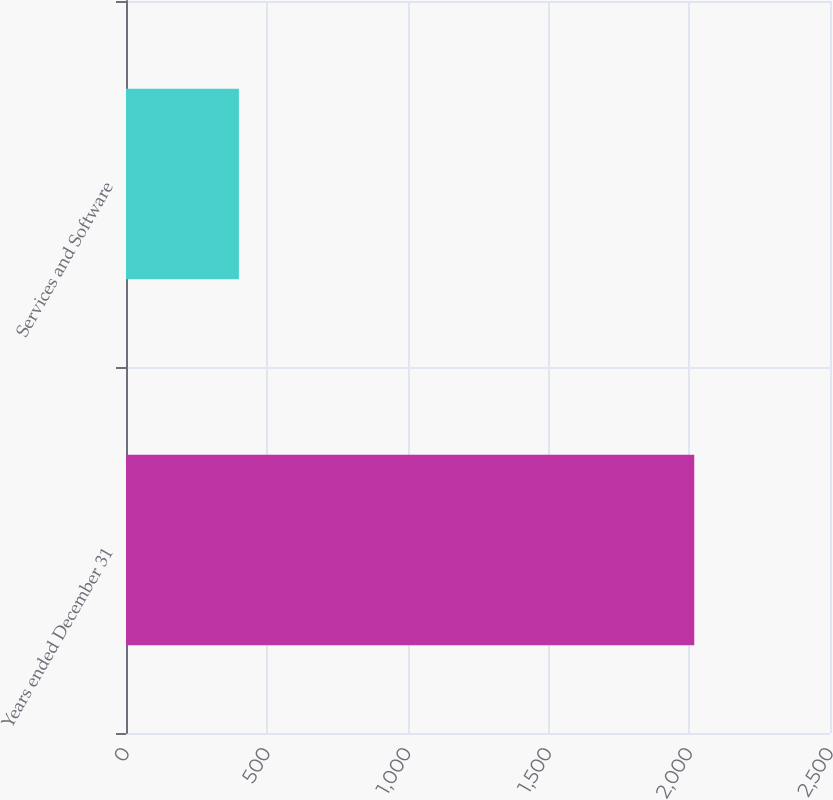Convert chart. <chart><loc_0><loc_0><loc_500><loc_500><bar_chart><fcel>Years ended December 31<fcel>Services and Software<nl><fcel>2018<fcel>401<nl></chart> 